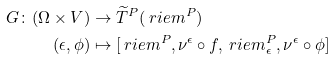Convert formula to latex. <formula><loc_0><loc_0><loc_500><loc_500>G \colon ( \Omega \times V ) & \to \widetilde { T } ^ { P } ( \ r i e m ^ { P } ) \\ ( \epsilon , \phi ) & \mapsto [ \ r i e m ^ { P } , \nu ^ { \epsilon } \circ f , \ r i e m ^ { P } _ { \epsilon } , \nu ^ { \epsilon } \circ \phi ]</formula> 